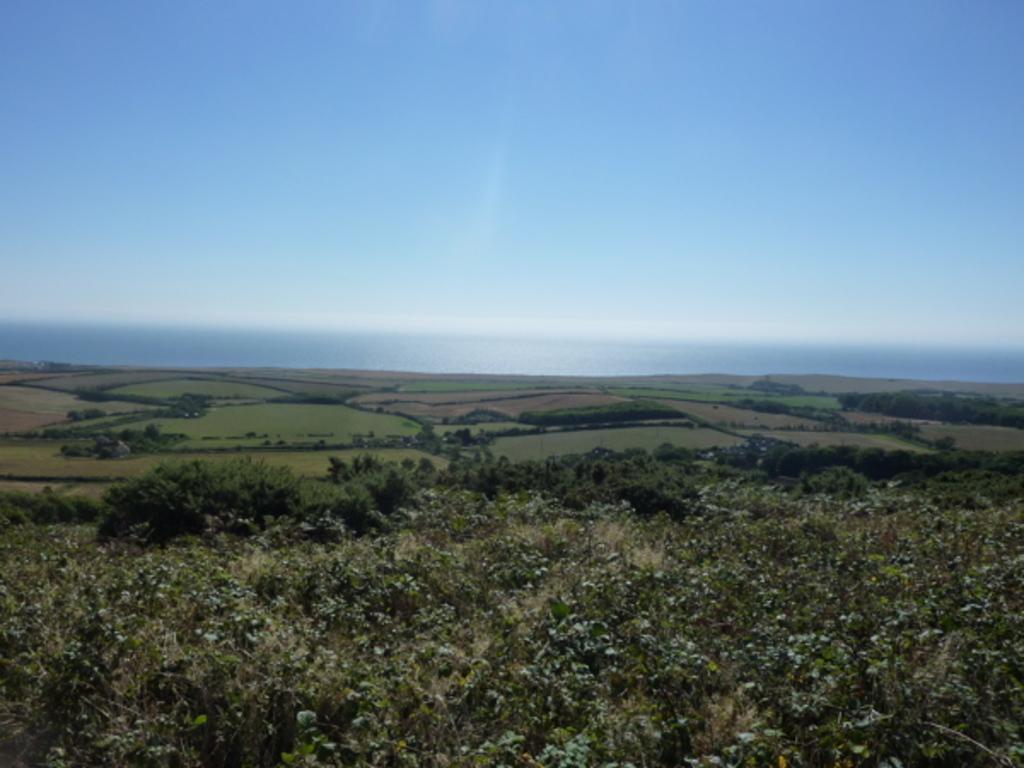Can you describe this image briefly? In this image we can see ground, plants, and trees. In the background there is sky. 